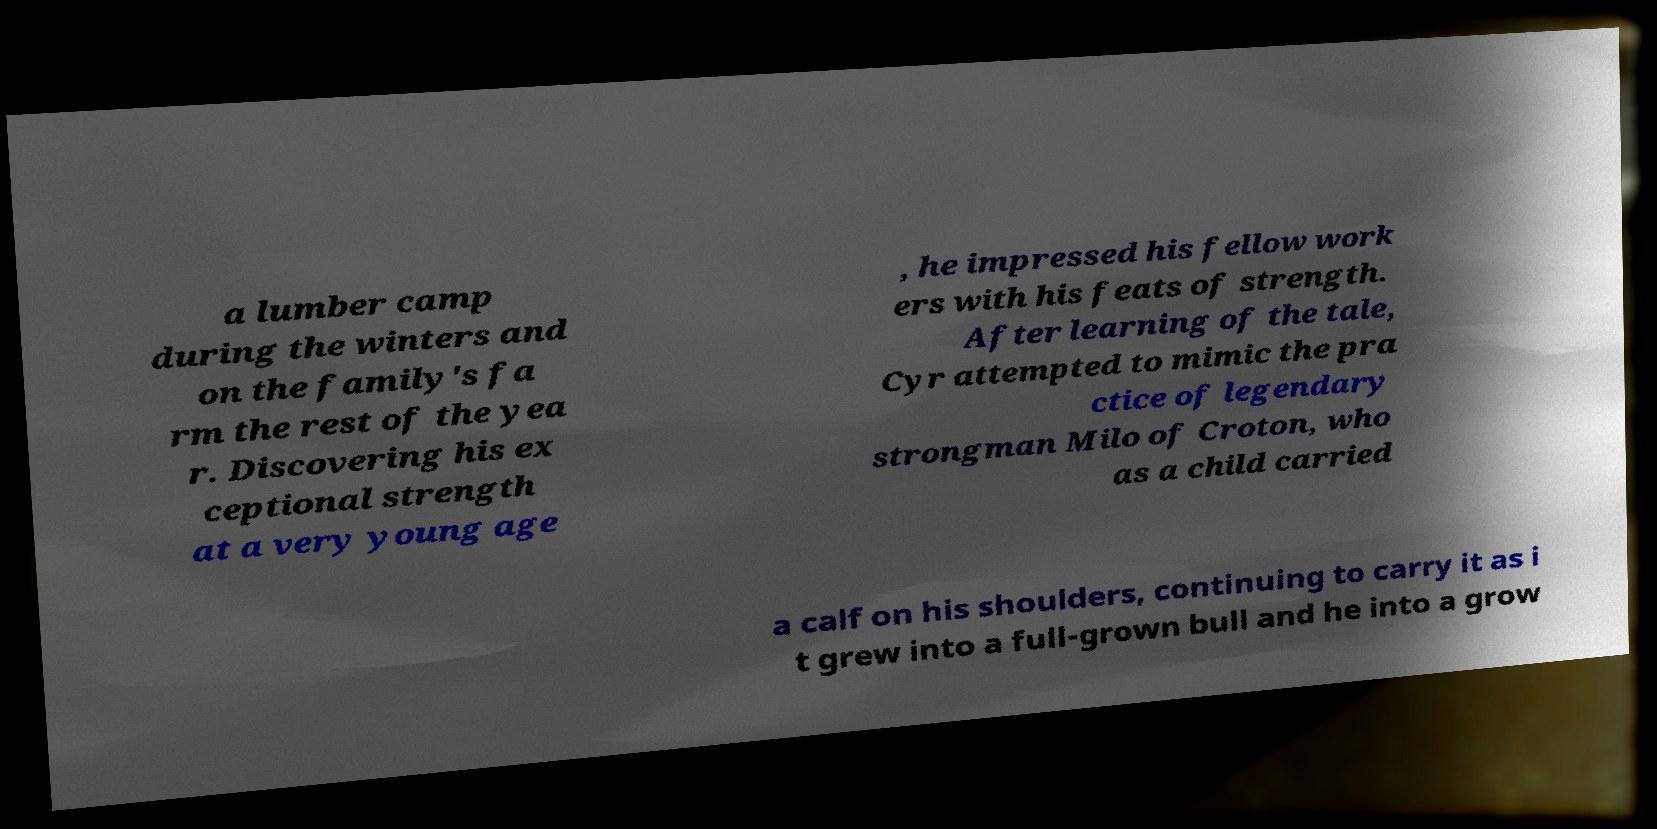Please identify and transcribe the text found in this image. a lumber camp during the winters and on the family's fa rm the rest of the yea r. Discovering his ex ceptional strength at a very young age , he impressed his fellow work ers with his feats of strength. After learning of the tale, Cyr attempted to mimic the pra ctice of legendary strongman Milo of Croton, who as a child carried a calf on his shoulders, continuing to carry it as i t grew into a full-grown bull and he into a grow 